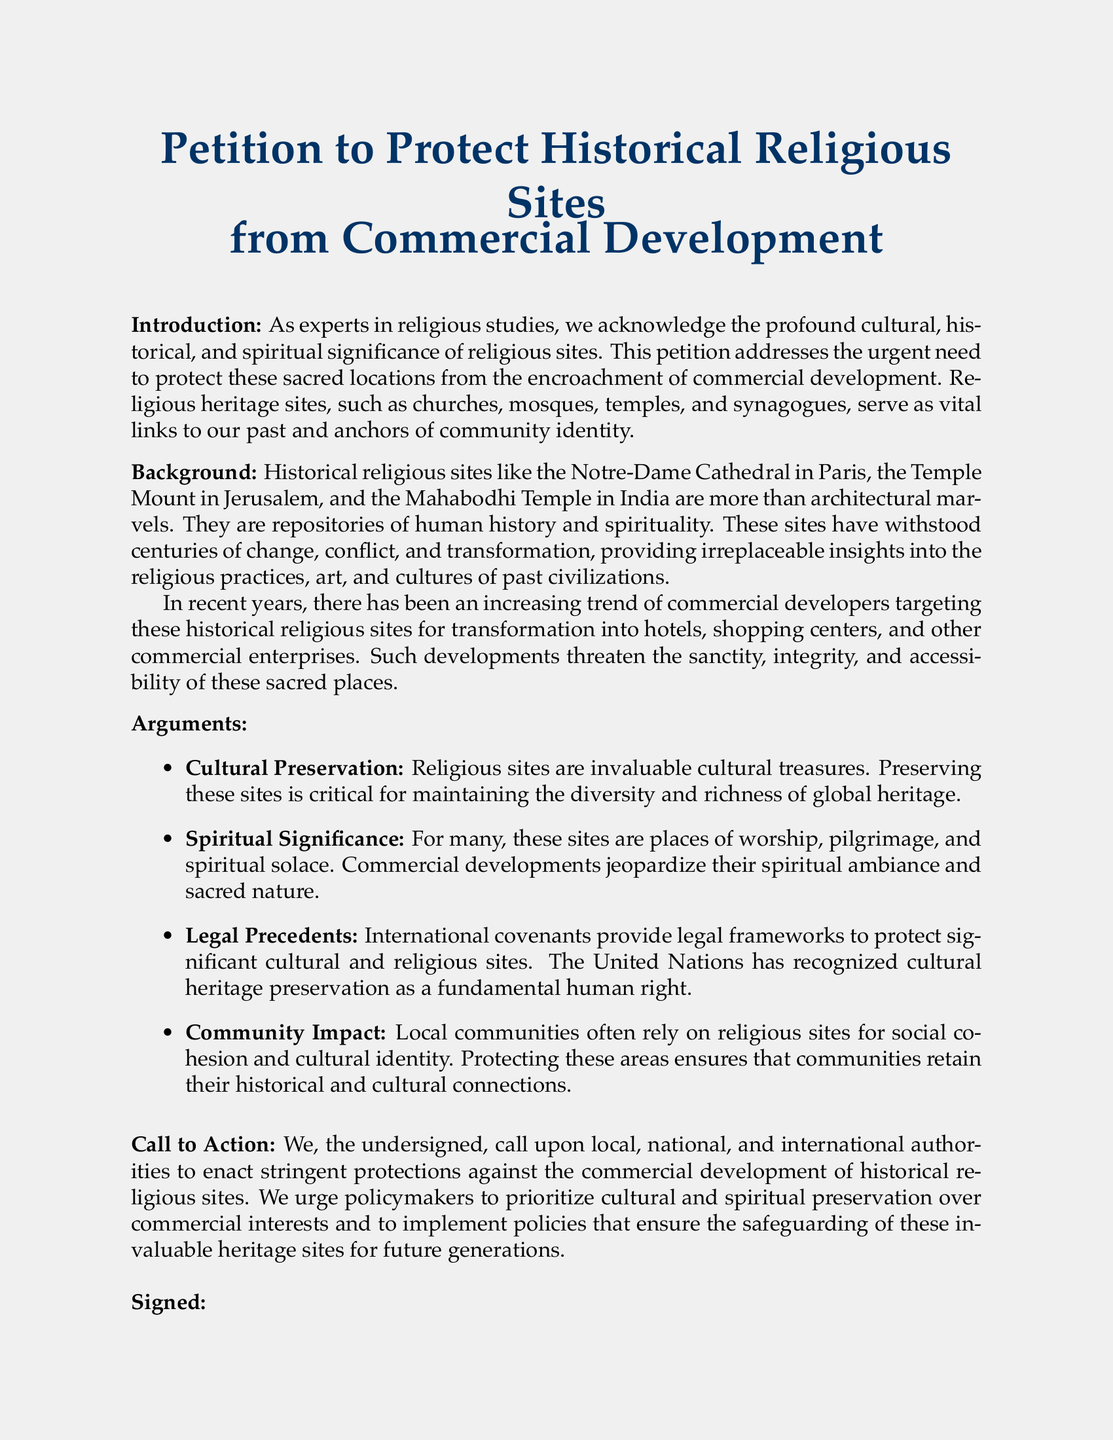What is the title of the petition? The title of the petition is prominently displayed in the document.
Answer: Petition to Protect Historical Religious Sites from Commercial Development What are examples of historical religious sites mentioned? The document lists several examples to illustrate significant religious sites.
Answer: Notre-Dame Cathedral, Temple Mount, Mahabodhi Temple What is one of the arguments for preservation? The document provides several arguments emphasizing the importance of preservation.
Answer: Cultural Preservation What does the petition urge authorities to prioritize? The petition outlines a clear call to action regarding priorities for authorities.
Answer: Cultural and spiritual preservation What is the required action from policymakers? The petition clearly indicates what actions are desired from policymakers regarding the sites.
Answer: Enact stringent protections How are the sites affected by commercial development? The document mentions the impact of commercial development in a broad sense.
Answer: Jeopardize their spiritual ambiance What does the petition recognize as a fundamental human right? The text references an internationally acknowledged right related to cultural and religious sites.
Answer: Cultural heritage preservation How many signatures are expected for the petition? The document does not specify an exact number of signatures but indicates a collective action.
Answer: Not specified What color is used for the main title in the document? The document specifies the color used for the title in its visual style.
Answer: Deep blue 